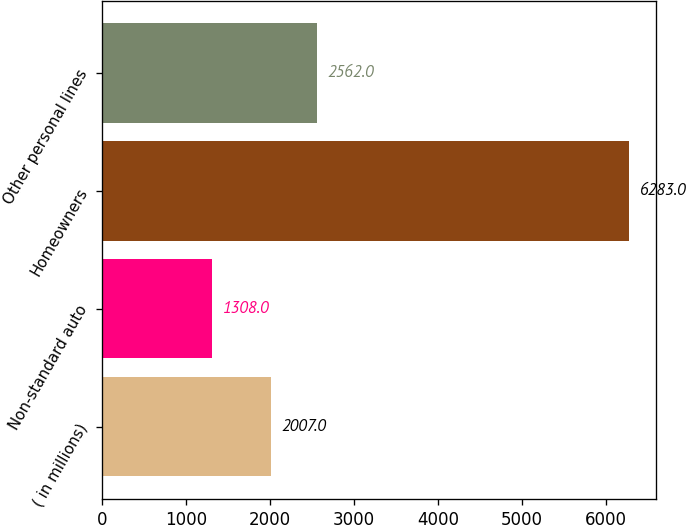Convert chart to OTSL. <chart><loc_0><loc_0><loc_500><loc_500><bar_chart><fcel>( in millions)<fcel>Non-standard auto<fcel>Homeowners<fcel>Other personal lines<nl><fcel>2007<fcel>1308<fcel>6283<fcel>2562<nl></chart> 